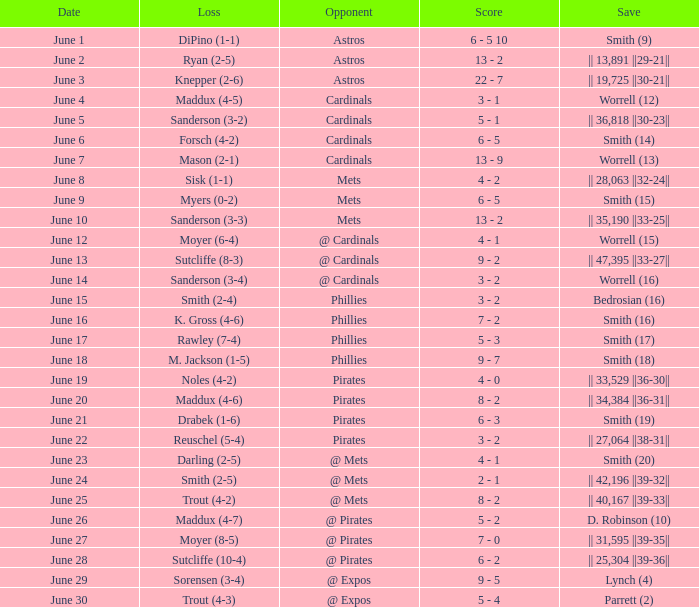The game that has a save of lynch (4) ended with what score? 9 - 5. 